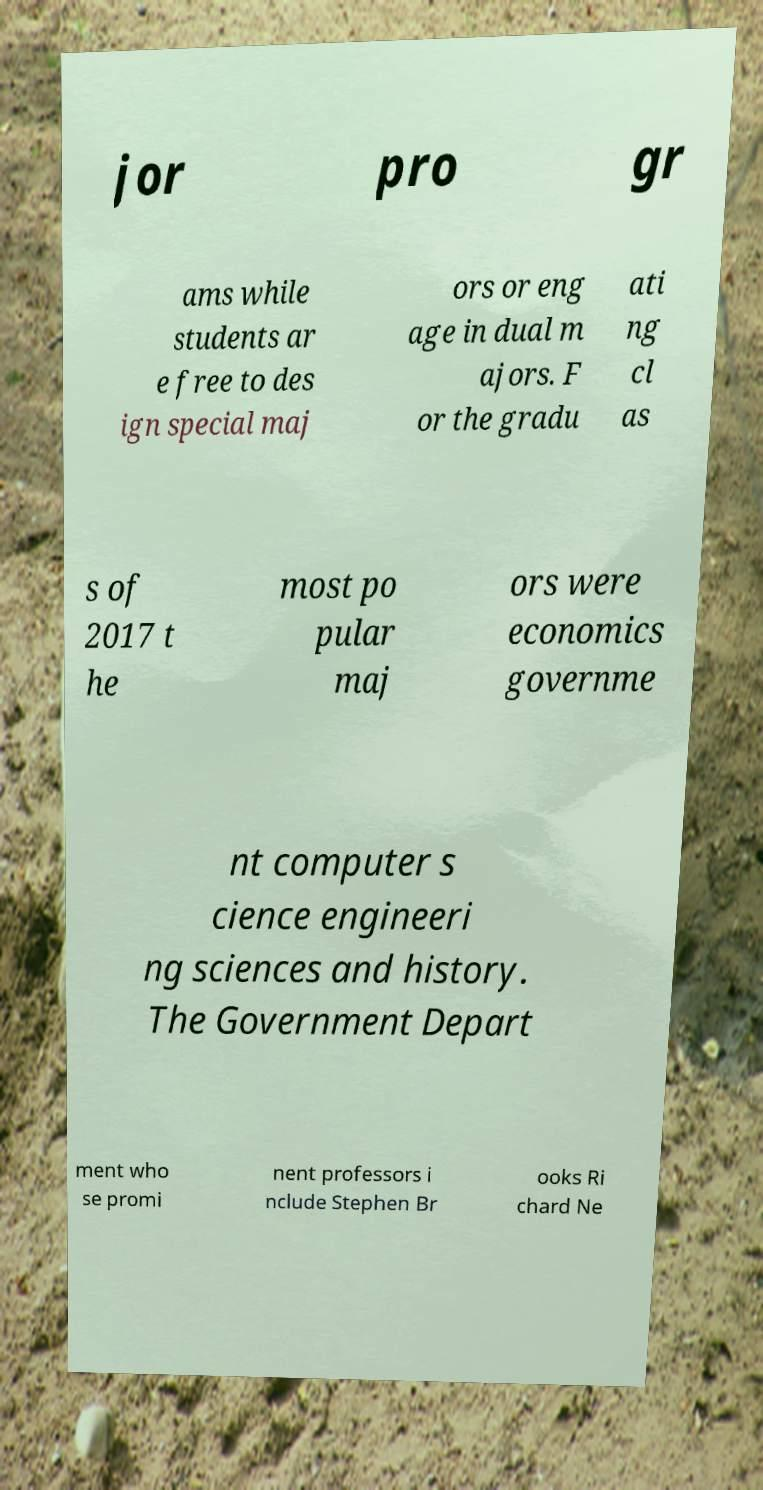Can you read and provide the text displayed in the image?This photo seems to have some interesting text. Can you extract and type it out for me? jor pro gr ams while students ar e free to des ign special maj ors or eng age in dual m ajors. F or the gradu ati ng cl as s of 2017 t he most po pular maj ors were economics governme nt computer s cience engineeri ng sciences and history. The Government Depart ment who se promi nent professors i nclude Stephen Br ooks Ri chard Ne 